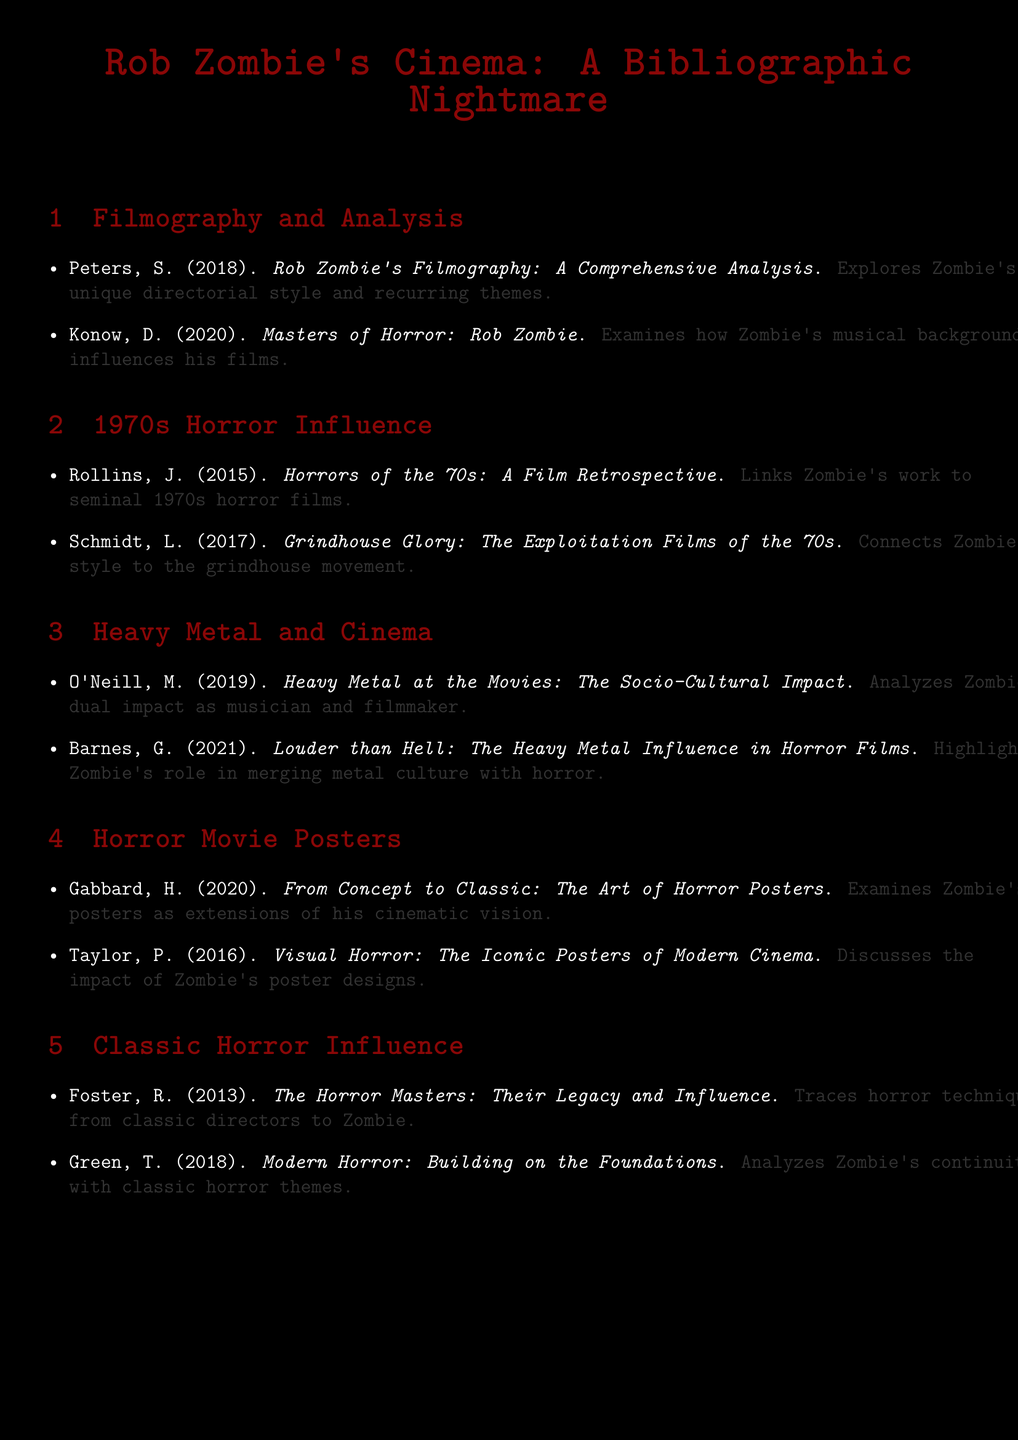What is the title of the first item in the filmography section? The first item listed in the filmography section is titled "Rob Zombie's Filmography: A Comprehensive Analysis."
Answer: Rob Zombie's Filmography: A Comprehensive Analysis Who wrote "Masters of Horror: Rob Zombie"? The author of "Masters of Horror: Rob Zombie" is D. Konow.
Answer: D. Konow Which decade is emphasized in the 1970s horror influence section? The decade emphasized in the section is the 1970s.
Answer: 1970s What is the main focus of M. O'Neill's work in the heavy metal and cinema section? M. O'Neill's work analyzes Zombie's dual impact as a musician and filmmaker.
Answer: Dual impact How many items are listed under the horror movie posters section? There are two items listed in the horror movie posters section.
Answer: 2 Which classic horror director's influence is discussed in R. Foster's work? R. Foster's work discusses the influence of classic horror directors.
Answer: Classic horror directors What is the primary theme covered in G. Barnes' work? The primary theme is the heavy metal influence in horror films.
Answer: Heavy metal influence Which author links Zombie's work to seminal 1970s horror films? The author who links Zombie's work to seminal 1970s horror films is J. Rollins.
Answer: J. Rollins 